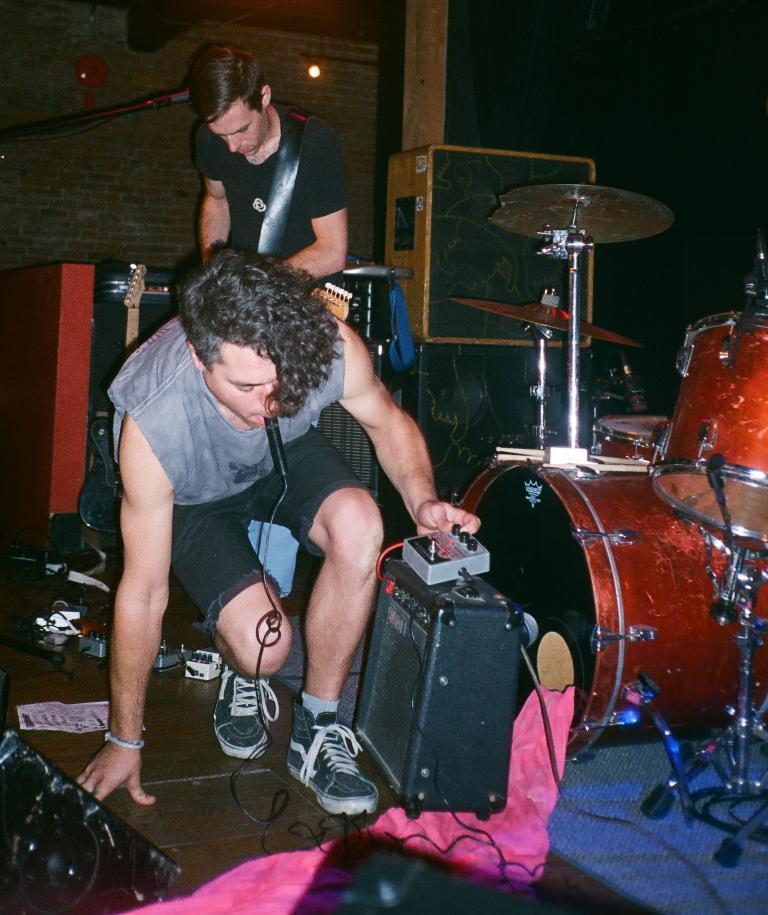In one or two sentences, can you explain what this image depicts? In this image, we can see persons wearing clothes. There are musical drums on the right side of the image. There are speakers and musical equipment in the middle of the image. There is a wall in the top left of the image. 